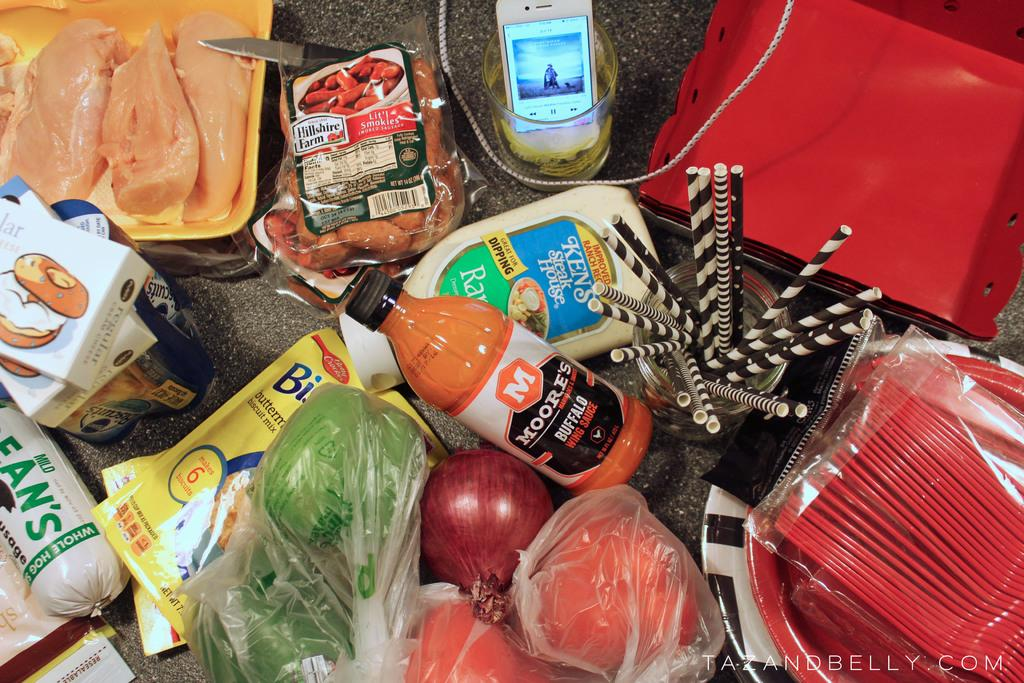What electronic device is present in the image? There is a mobile phone in the image. What utensil can be seen in the image? There is a knife in the image. What type of food items are visible in the image? There are packed foods, cartons, chocolate rolls, and vegetables in the image. What else can be found in the image? There are cables in the image. What part of the room can be seen in the image? The floor is visible in the image. Where is the kite being flown in the image? There is no kite present in the image. What is the end result of the camping trip in the image? There is no camping trip or end result depicted in the image. 